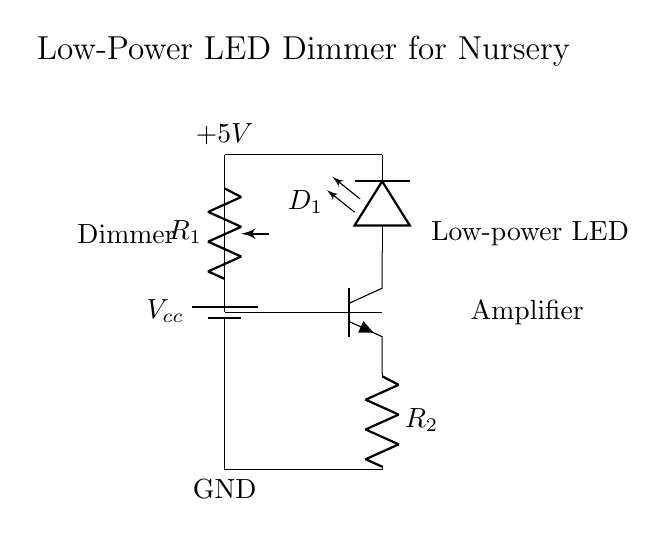What is the type of battery used in this circuit? The circuit diagram shows a battery labeled with "Vcc," which typically indicates a direct current (DC) power source, specifically a battery.
Answer: Battery What is the purpose of the potentiometer in this circuit? The potentiometer labeled as "R1" allows for dimming the LED by varying the resistance, thereby controlling the current flowing through the LED, which adjusts its brightness.
Answer: Dimming What current flows through the LED when fully dimmed? While the exact current value is not given, the circuit uses a low-power LED typically operated in the range of 10 to 20 milliamperes. When fully dimmed, it would approach zero current.
Answer: Zero Which component acts as the amplifier in this circuit? The transistor labeled as "npn" is functioning as the amplifier, as it amplifies the current from the potentiometer to control the LED's brightness.
Answer: Transistor What is the ground reference in this circuit? The ground reference is indicated by "GND" at the bottom of the diagram, representing zero voltage in relation to the other components in the circuit.
Answer: GND What is the role of resistor R2 in this circuit? Resistor R2 provides a path to ground for the transistor's emitter, helping to stabilize the transistor's operation, and influences the current flowing through the LED.
Answer: Stabilization What voltage is supplied to the LED in this circuit? The LED is supplied with a voltage of 5V, which is the same as the voltage labeled "Vcc" in the circuit diagram.
Answer: 5V 